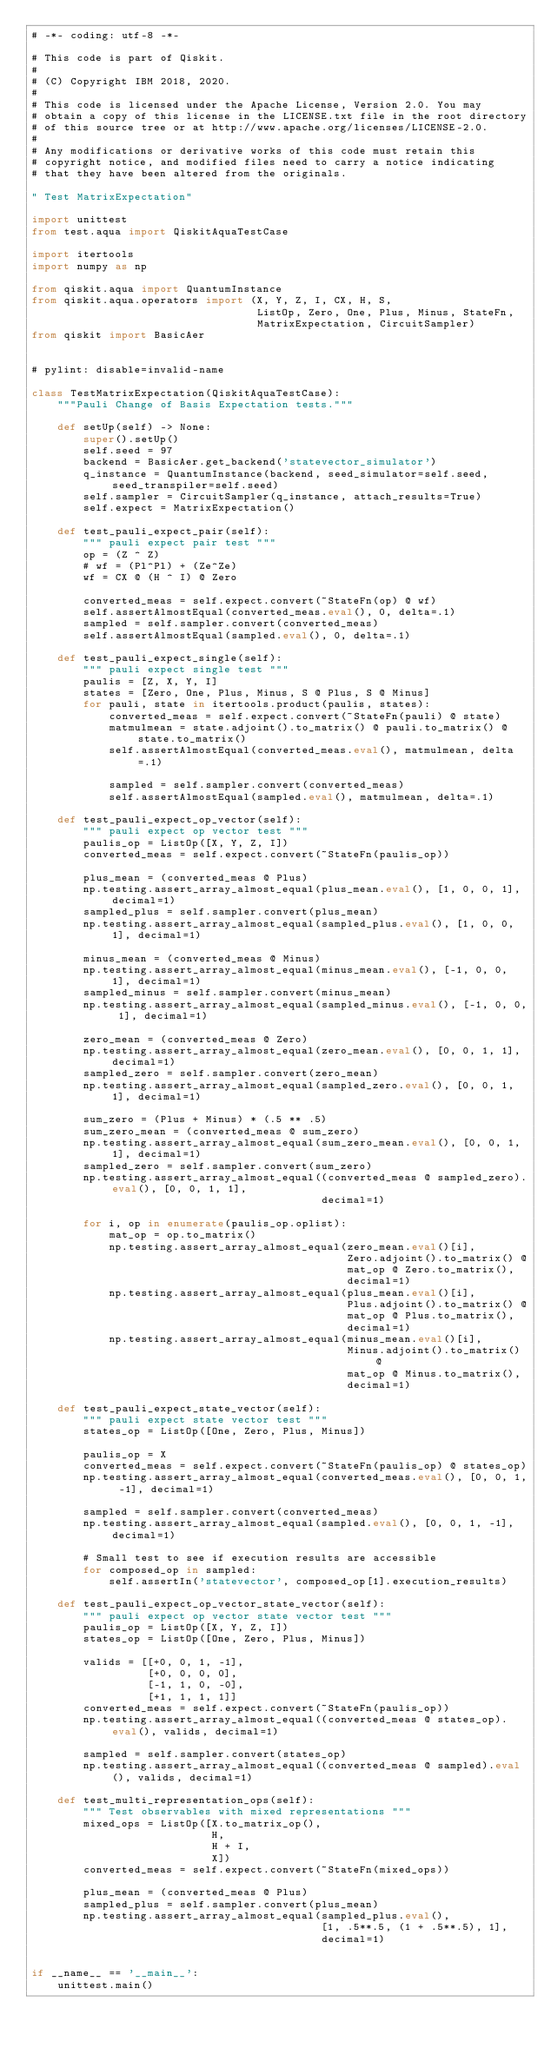<code> <loc_0><loc_0><loc_500><loc_500><_Python_># -*- coding: utf-8 -*-

# This code is part of Qiskit.
#
# (C) Copyright IBM 2018, 2020.
#
# This code is licensed under the Apache License, Version 2.0. You may
# obtain a copy of this license in the LICENSE.txt file in the root directory
# of this source tree or at http://www.apache.org/licenses/LICENSE-2.0.
#
# Any modifications or derivative works of this code must retain this
# copyright notice, and modified files need to carry a notice indicating
# that they have been altered from the originals.

" Test MatrixExpectation"

import unittest
from test.aqua import QiskitAquaTestCase

import itertools
import numpy as np

from qiskit.aqua import QuantumInstance
from qiskit.aqua.operators import (X, Y, Z, I, CX, H, S,
                                   ListOp, Zero, One, Plus, Minus, StateFn,
                                   MatrixExpectation, CircuitSampler)
from qiskit import BasicAer


# pylint: disable=invalid-name

class TestMatrixExpectation(QiskitAquaTestCase):
    """Pauli Change of Basis Expectation tests."""

    def setUp(self) -> None:
        super().setUp()
        self.seed = 97
        backend = BasicAer.get_backend('statevector_simulator')
        q_instance = QuantumInstance(backend, seed_simulator=self.seed, seed_transpiler=self.seed)
        self.sampler = CircuitSampler(q_instance, attach_results=True)
        self.expect = MatrixExpectation()

    def test_pauli_expect_pair(self):
        """ pauli expect pair test """
        op = (Z ^ Z)
        # wf = (Pl^Pl) + (Ze^Ze)
        wf = CX @ (H ^ I) @ Zero

        converted_meas = self.expect.convert(~StateFn(op) @ wf)
        self.assertAlmostEqual(converted_meas.eval(), 0, delta=.1)
        sampled = self.sampler.convert(converted_meas)
        self.assertAlmostEqual(sampled.eval(), 0, delta=.1)

    def test_pauli_expect_single(self):
        """ pauli expect single test """
        paulis = [Z, X, Y, I]
        states = [Zero, One, Plus, Minus, S @ Plus, S @ Minus]
        for pauli, state in itertools.product(paulis, states):
            converted_meas = self.expect.convert(~StateFn(pauli) @ state)
            matmulmean = state.adjoint().to_matrix() @ pauli.to_matrix() @ state.to_matrix()
            self.assertAlmostEqual(converted_meas.eval(), matmulmean, delta=.1)

            sampled = self.sampler.convert(converted_meas)
            self.assertAlmostEqual(sampled.eval(), matmulmean, delta=.1)

    def test_pauli_expect_op_vector(self):
        """ pauli expect op vector test """
        paulis_op = ListOp([X, Y, Z, I])
        converted_meas = self.expect.convert(~StateFn(paulis_op))

        plus_mean = (converted_meas @ Plus)
        np.testing.assert_array_almost_equal(plus_mean.eval(), [1, 0, 0, 1], decimal=1)
        sampled_plus = self.sampler.convert(plus_mean)
        np.testing.assert_array_almost_equal(sampled_plus.eval(), [1, 0, 0, 1], decimal=1)

        minus_mean = (converted_meas @ Minus)
        np.testing.assert_array_almost_equal(minus_mean.eval(), [-1, 0, 0, 1], decimal=1)
        sampled_minus = self.sampler.convert(minus_mean)
        np.testing.assert_array_almost_equal(sampled_minus.eval(), [-1, 0, 0, 1], decimal=1)

        zero_mean = (converted_meas @ Zero)
        np.testing.assert_array_almost_equal(zero_mean.eval(), [0, 0, 1, 1], decimal=1)
        sampled_zero = self.sampler.convert(zero_mean)
        np.testing.assert_array_almost_equal(sampled_zero.eval(), [0, 0, 1, 1], decimal=1)

        sum_zero = (Plus + Minus) * (.5 ** .5)
        sum_zero_mean = (converted_meas @ sum_zero)
        np.testing.assert_array_almost_equal(sum_zero_mean.eval(), [0, 0, 1, 1], decimal=1)
        sampled_zero = self.sampler.convert(sum_zero)
        np.testing.assert_array_almost_equal((converted_meas @ sampled_zero).eval(), [0, 0, 1, 1],
                                             decimal=1)

        for i, op in enumerate(paulis_op.oplist):
            mat_op = op.to_matrix()
            np.testing.assert_array_almost_equal(zero_mean.eval()[i],
                                                 Zero.adjoint().to_matrix() @
                                                 mat_op @ Zero.to_matrix(),
                                                 decimal=1)
            np.testing.assert_array_almost_equal(plus_mean.eval()[i],
                                                 Plus.adjoint().to_matrix() @
                                                 mat_op @ Plus.to_matrix(),
                                                 decimal=1)
            np.testing.assert_array_almost_equal(minus_mean.eval()[i],
                                                 Minus.adjoint().to_matrix() @
                                                 mat_op @ Minus.to_matrix(),
                                                 decimal=1)

    def test_pauli_expect_state_vector(self):
        """ pauli expect state vector test """
        states_op = ListOp([One, Zero, Plus, Minus])

        paulis_op = X
        converted_meas = self.expect.convert(~StateFn(paulis_op) @ states_op)
        np.testing.assert_array_almost_equal(converted_meas.eval(), [0, 0, 1, -1], decimal=1)

        sampled = self.sampler.convert(converted_meas)
        np.testing.assert_array_almost_equal(sampled.eval(), [0, 0, 1, -1], decimal=1)

        # Small test to see if execution results are accessible
        for composed_op in sampled:
            self.assertIn('statevector', composed_op[1].execution_results)

    def test_pauli_expect_op_vector_state_vector(self):
        """ pauli expect op vector state vector test """
        paulis_op = ListOp([X, Y, Z, I])
        states_op = ListOp([One, Zero, Plus, Minus])

        valids = [[+0, 0, 1, -1],
                  [+0, 0, 0, 0],
                  [-1, 1, 0, -0],
                  [+1, 1, 1, 1]]
        converted_meas = self.expect.convert(~StateFn(paulis_op))
        np.testing.assert_array_almost_equal((converted_meas @ states_op).eval(), valids, decimal=1)

        sampled = self.sampler.convert(states_op)
        np.testing.assert_array_almost_equal((converted_meas @ sampled).eval(), valids, decimal=1)

    def test_multi_representation_ops(self):
        """ Test observables with mixed representations """
        mixed_ops = ListOp([X.to_matrix_op(),
                            H,
                            H + I,
                            X])
        converted_meas = self.expect.convert(~StateFn(mixed_ops))

        plus_mean = (converted_meas @ Plus)
        sampled_plus = self.sampler.convert(plus_mean)
        np.testing.assert_array_almost_equal(sampled_plus.eval(),
                                             [1, .5**.5, (1 + .5**.5), 1],
                                             decimal=1)


if __name__ == '__main__':
    unittest.main()
</code> 